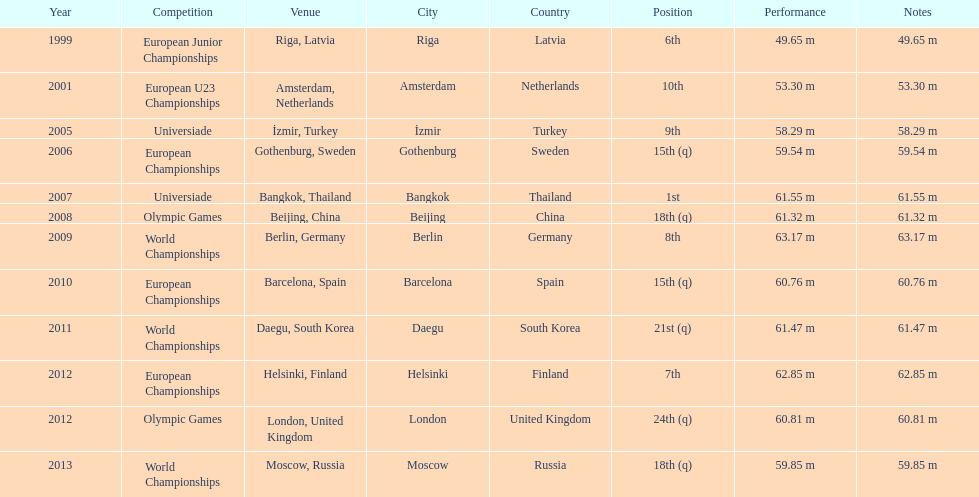Prior to 2007, what was the highest place achieved? 6th. 